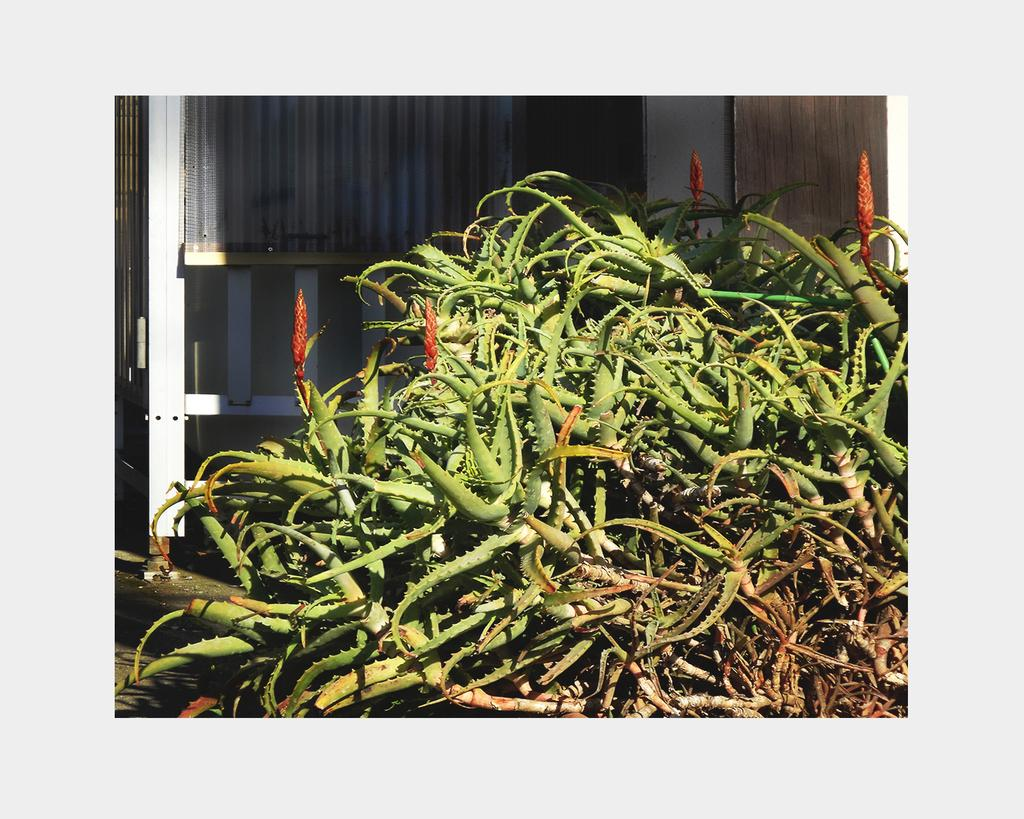What type of plants are in the image? There are aloe vera plants in the image. Can you describe the appearance of the aloe vera plants? The aloe vera plants have thick, fleshy leaves that grow in a rosette pattern. Are there any other plants or objects visible in the image? The image only shows aloe vera plants. What type of bath can be seen in the image? There is no bath present in the image; it only shows aloe vera plants. Is there a partner standing next to the aloe vera plants in the image? There is no partner present in the image; it only shows aloe vera plants. 